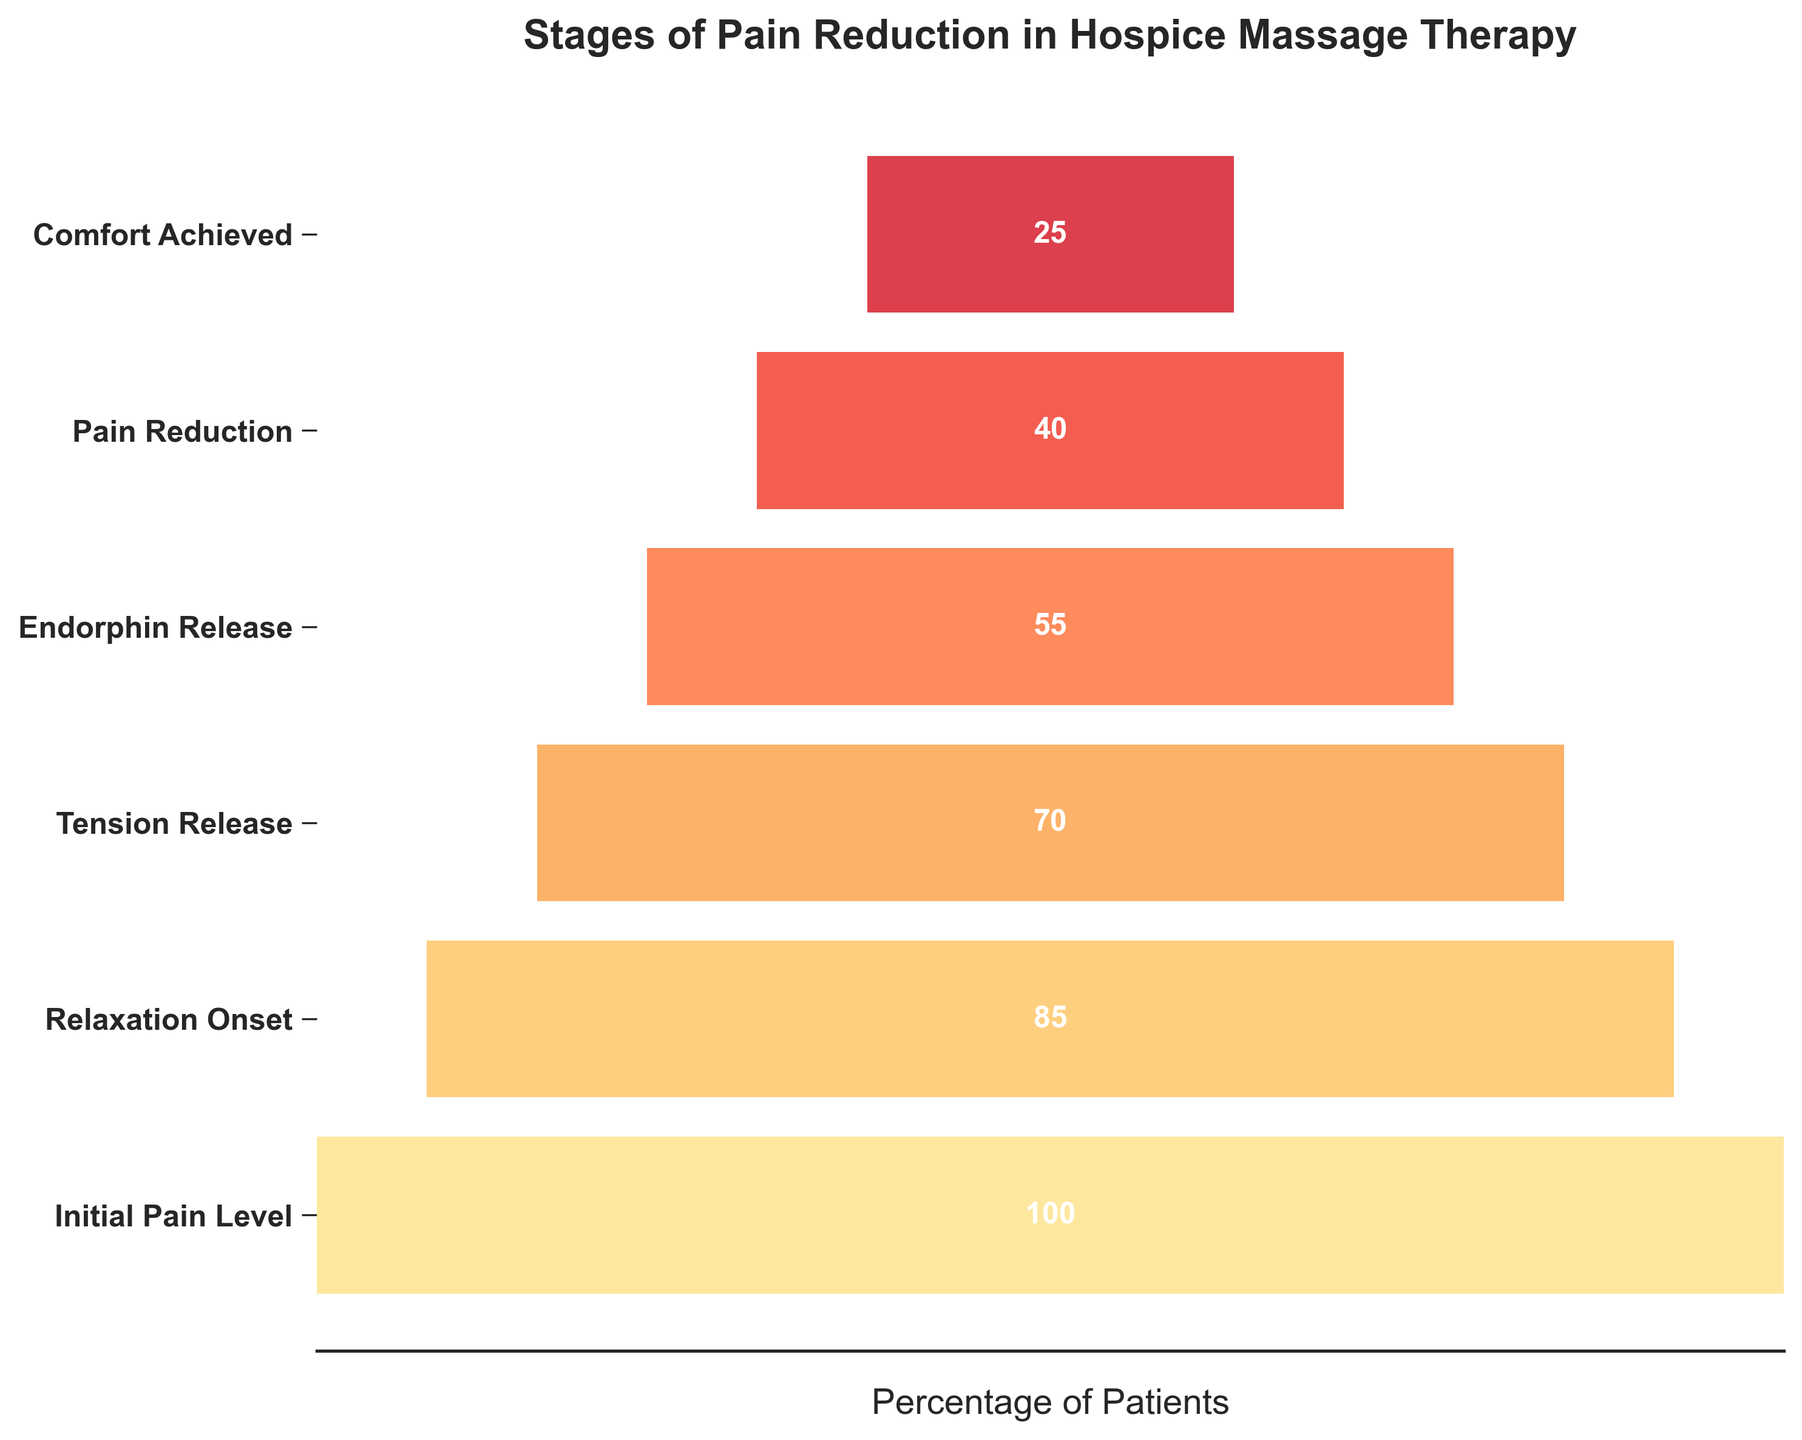What is the title of the funnel chart? The title of the funnel chart is displayed prominently at the top and reads 'Stages of Pain Reduction in Hospice Massage Therapy'.
Answer: Stages of Pain Reduction in Hospice Massage Therapy How many stages are shown in the funnel chart? The y-axis of the funnel chart lists the stages, and there are six labeled stages from 'Initial Pain Level' to 'Comfort Achieved'.
Answer: Six What stage has the highest number of patients? The first stage, 'Initial Pain Level', has the highest number of patients at 100, as this is where the funnel starts.
Answer: Initial Pain Level What stage has the lowest number of patients? The last stage, 'Comfort Achieved', has the lowest number of patients with a count of 25, as displayed at the bottom of the funnel.
Answer: Comfort Achieved How many patients experience a reduction from 'Relaxation Onset' to 'Tension Release'? Subtract the number of patients at 'Tension Release' (70) from the number at 'Relaxation Onset' (85), resulting in a reduction of 15 patients.
Answer: 15 What is the median number of patients across all stages? Listed stages have patient counts of 100, 85, 70, 55, 40, and 25. Arrange these numbers in ascending order, then the median is the average of the third (55) and fourth (70) numbers: (55 + 70) / 2 = 62.5.
Answer: 62.5 Which stage sees the greatest reduction in the number of patients? Compare the difference between consecutive stages: the greatest reduction is from 'Endorphin Release' (55) to 'Pain Reduction' (40), a reduction of 15.
Answer: Endorphin Release to Pain Reduction By what percentage do patients reduce from 'Initial Pain Level' to 'Comfort Achieved'? Starting at 100 patients ('Initial Pain Level') and dropping to 25 ('Comfort Achieved') is a reduction of 75 patients. The percentage reduction is (75 / 100) * 100 = 75%.
Answer: 75% How do the colors of the bars change as you move through the stages? The colors of the bars change in a gradient from lighter to darker shades of a warm palette (yellow to red), indicating a shift from initial to final stages.
Answer: From yellow to red What could be inferred if the width of the bars does not decrease progressively? If the width of the bars does not decrease progressively, it may indicate inconsistency in improvements, reflecting that the number of patients regaining comfort may not steadily decline at each stage.
Answer: Inconsistent improvements 